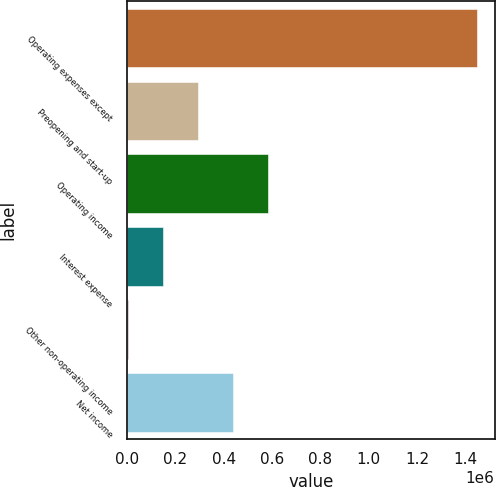Convert chart to OTSL. <chart><loc_0><loc_0><loc_500><loc_500><bar_chart><fcel>Operating expenses except<fcel>Preopening and start-up<fcel>Operating income<fcel>Interest expense<fcel>Other non-operating income<fcel>Net income<nl><fcel>1.44775e+06<fcel>293705<fcel>582216<fcel>149450<fcel>5194<fcel>437960<nl></chart> 